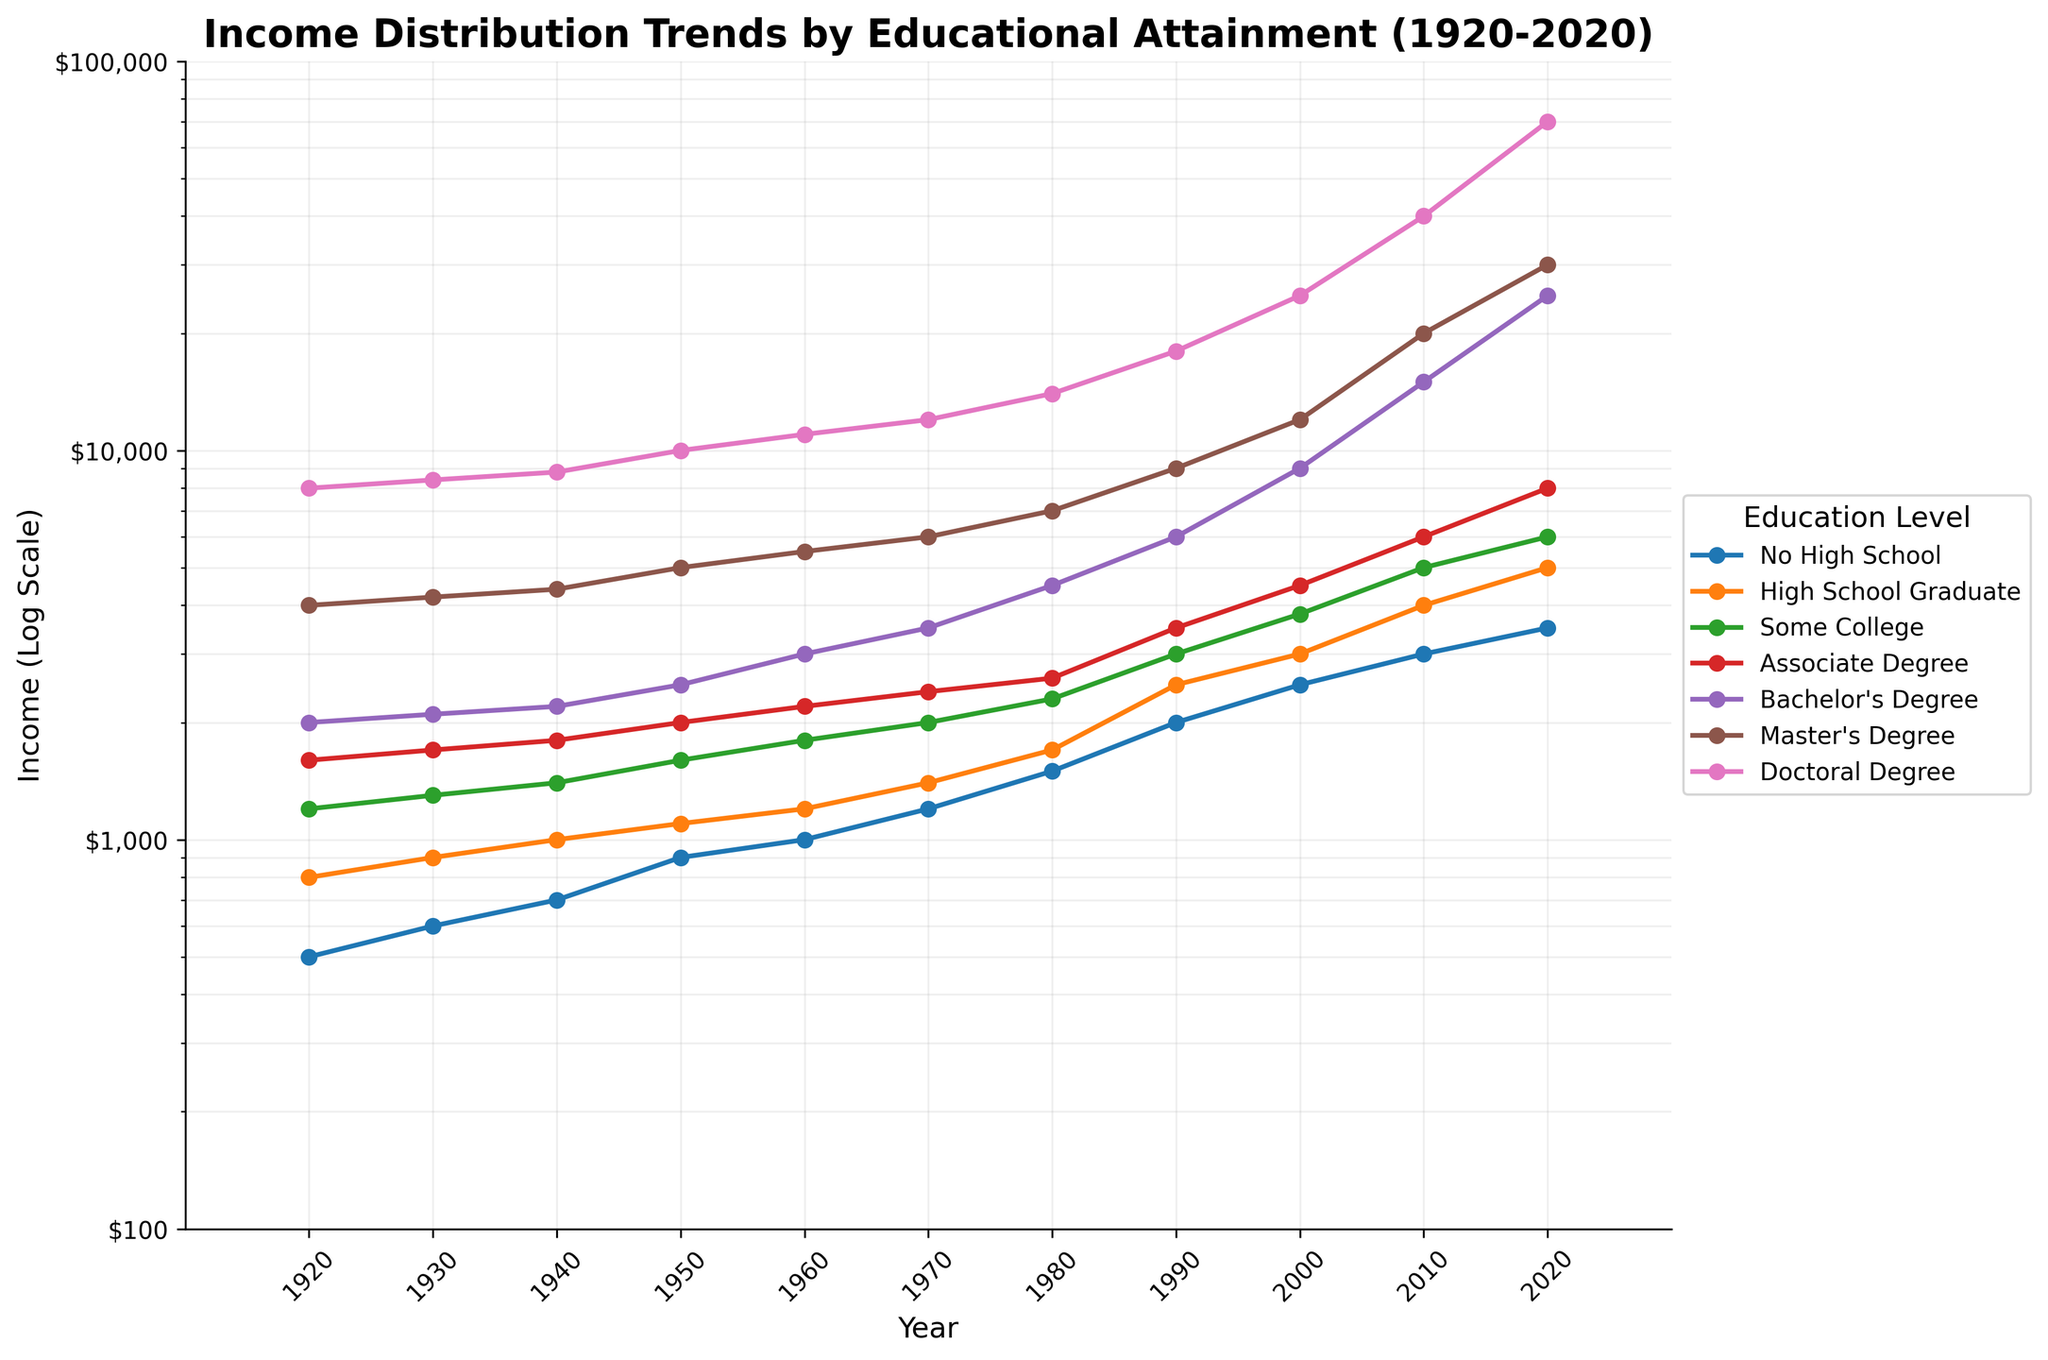What is the title of the figure? The title of a figure is usually found at the top and describes what the figure is about. Reading the top of the figure, the title is "Income Distribution Trends by Educational Attainment (1920-2020)."
Answer: Income Distribution Trends by Educational Attainment (1920-2020) Which education level had the highest income in 2020? To determine which education level had the highest income in 2020, trace upwards from the '2020' label on the x-axis and identify the highest point among the lines. The highest point is for the Doctoral Degree.
Answer: Doctoral Degree How has the income for high school graduates changed from 1920 to 2020? Look at the 'High School Graduate' line and compare its position in 1920 and 2020. In 1920, the income was $800 and has increased to $5000 in 2020.
Answer: Increased from $800 to $5000 What is the income difference between Bachelor's Degree and Master's Degree holders in 1980? Find the points for Bachelor's Degree and Master's Degree on the graph in 1980. Bachelor's Degree is at $4500, and Master's Degree is at $7000. The difference is $7000 - $4500.
Answer: $2500 Which education level showed the most significant income growth between 2000 and 2020? Compare the points for all education levels between 2000 and 2020. The Doctoral Degree grew from $25000 to $70000, which is an increase of $45000. This is the most significant growth.
Answer: Doctoral Degree Did any education level's income decrease at any point in time from 1920 to 2020? Track each line from left to right and see if any of them drop at any point. None of the lines show a decrease at any point. They all show a pattern of increase or stay constant.
Answer: No What range of income is shown on the y-axis in the log scale? The y-axis has labels indicating income levels. The range is from $100 to $100,000.
Answer: $100 to $100,000 Which education levels had incomes above $10,000 in 2000? Look for the points in 2000 and see which are above $10,000. These points correspond to Master's Degree ($12,000) and Doctoral Degree ($25,000).
Answer: Master's Degree and Doctoral Degree Has the income for each educational level increased steadily over time? Check each line from left (1920) to right (2020) and see if the line shows continuous upward movement without dips. All the lines show a steady increase over time.
Answer: Yes Between which decades did Bachelor's Degree holders see the most dramatic increase in income? Observe the line for Bachelor's Degree and look for the steepest section. The most significant increase appears between 2010 and 2020, where it jumps from $15,000 to $25,000.
Answer: 2010 to 2020 